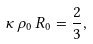Convert formula to latex. <formula><loc_0><loc_0><loc_500><loc_500>\kappa \, \rho _ { 0 } \, R _ { 0 } = \frac { 2 } { 3 } ,</formula> 